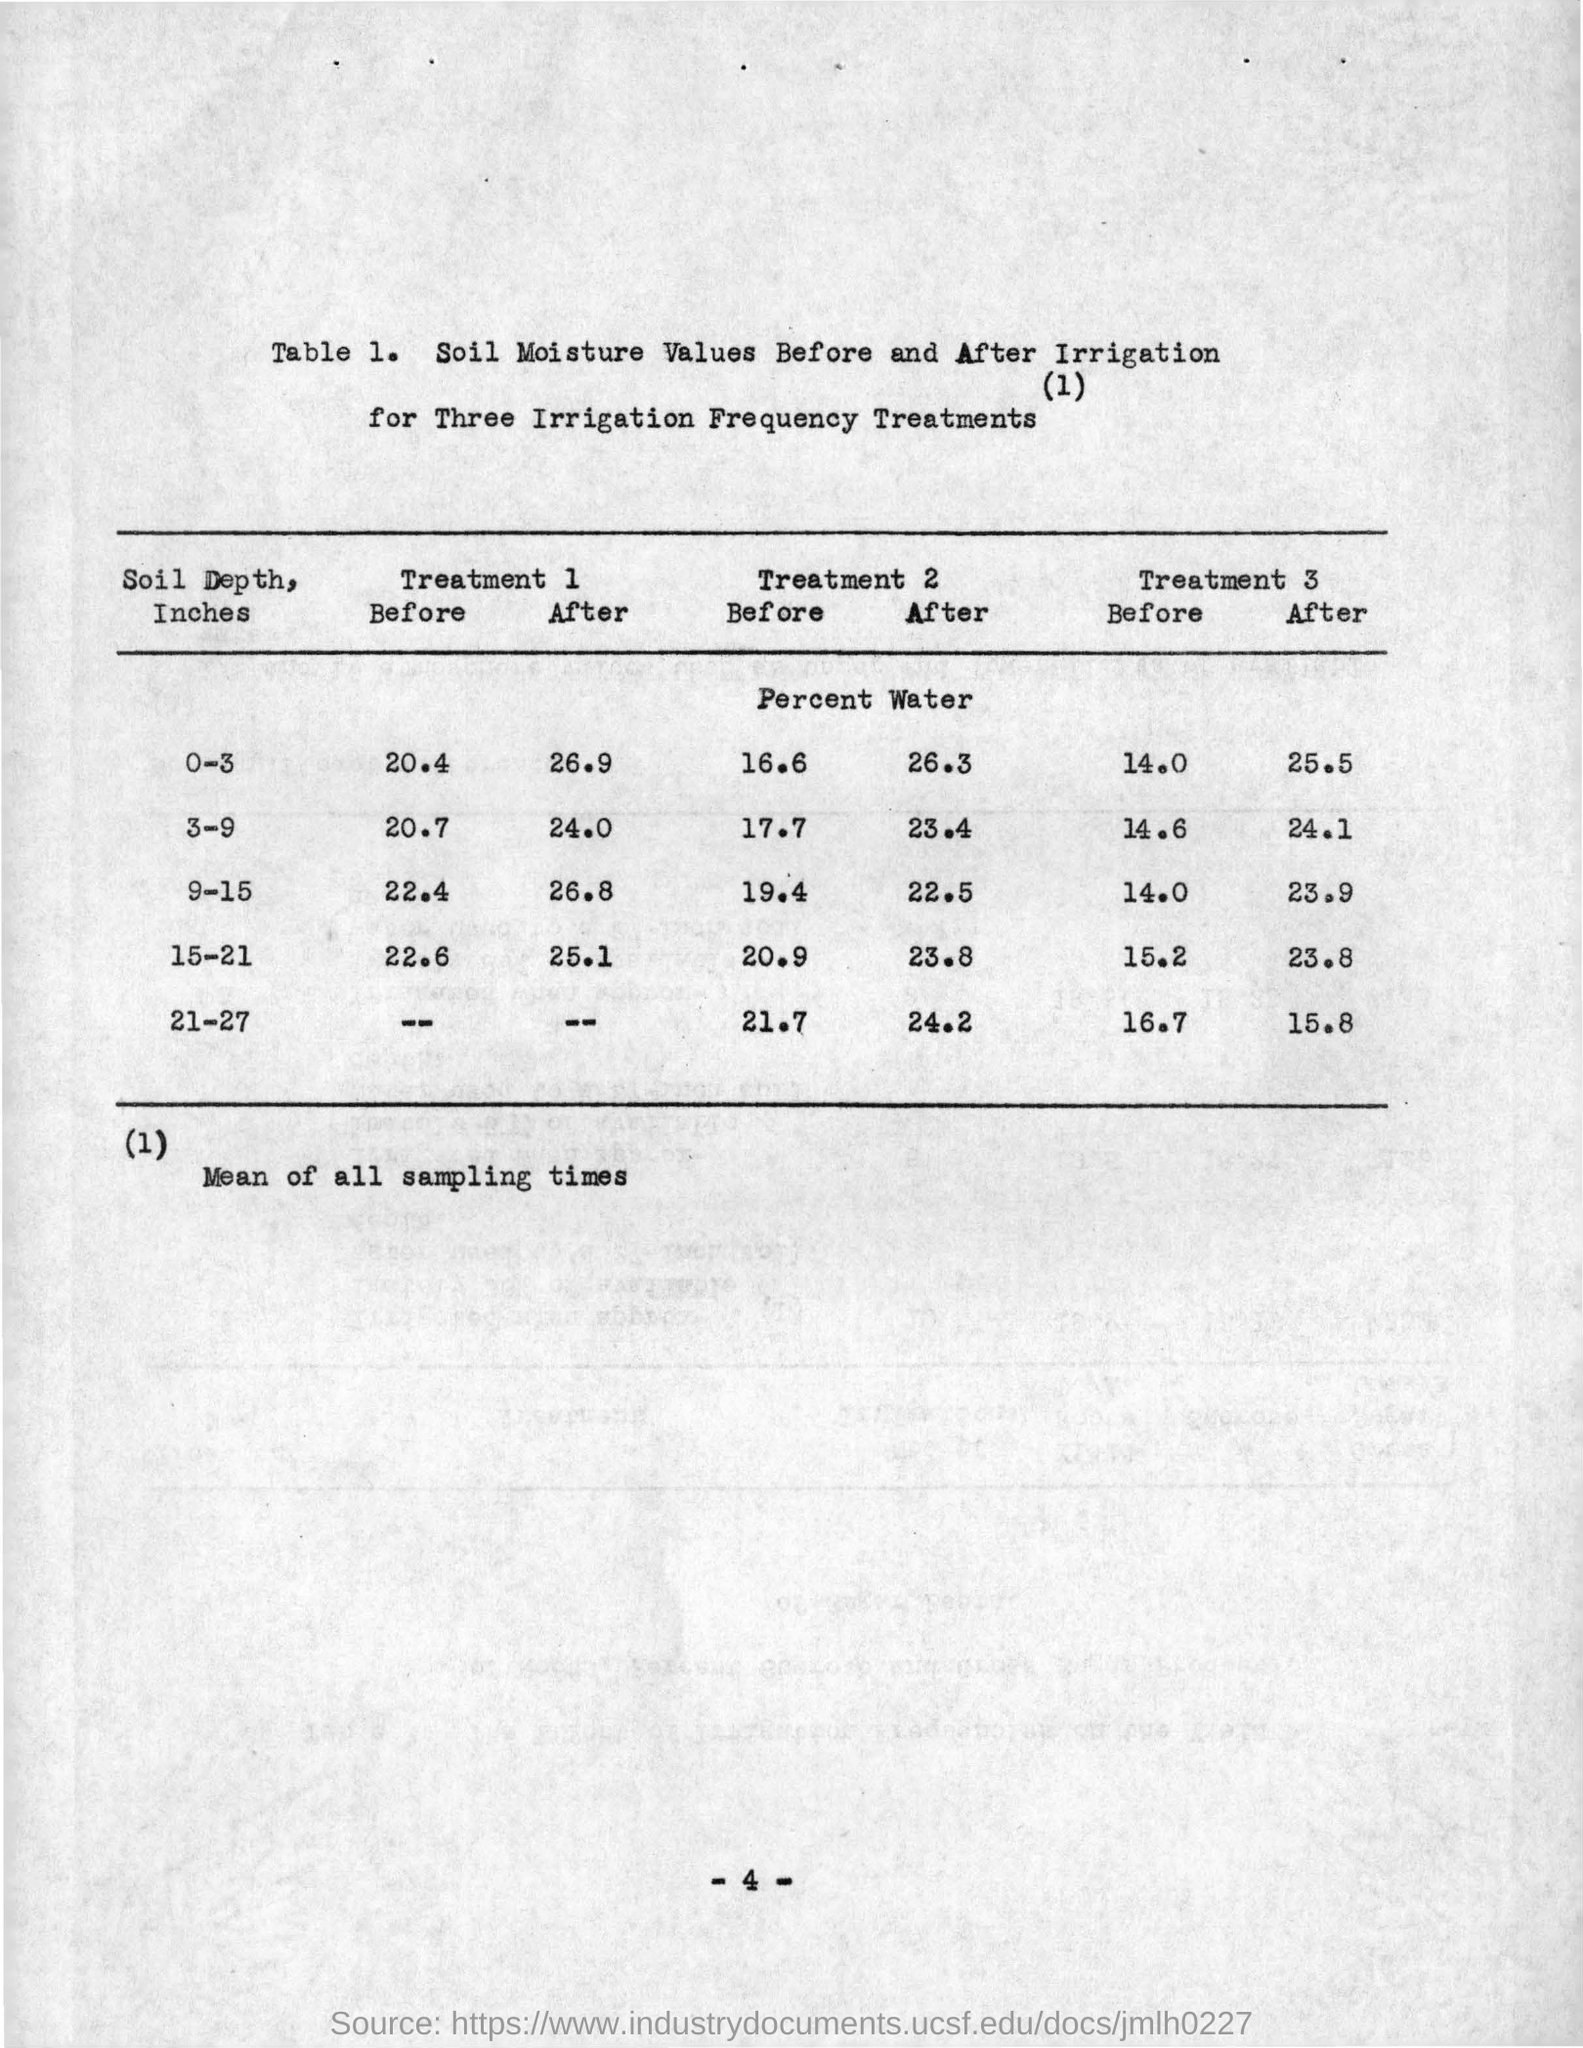Point out several critical features in this image. What table number is mentioned in the document? It is Table 1. The mean of all sampling times is written below the table. 